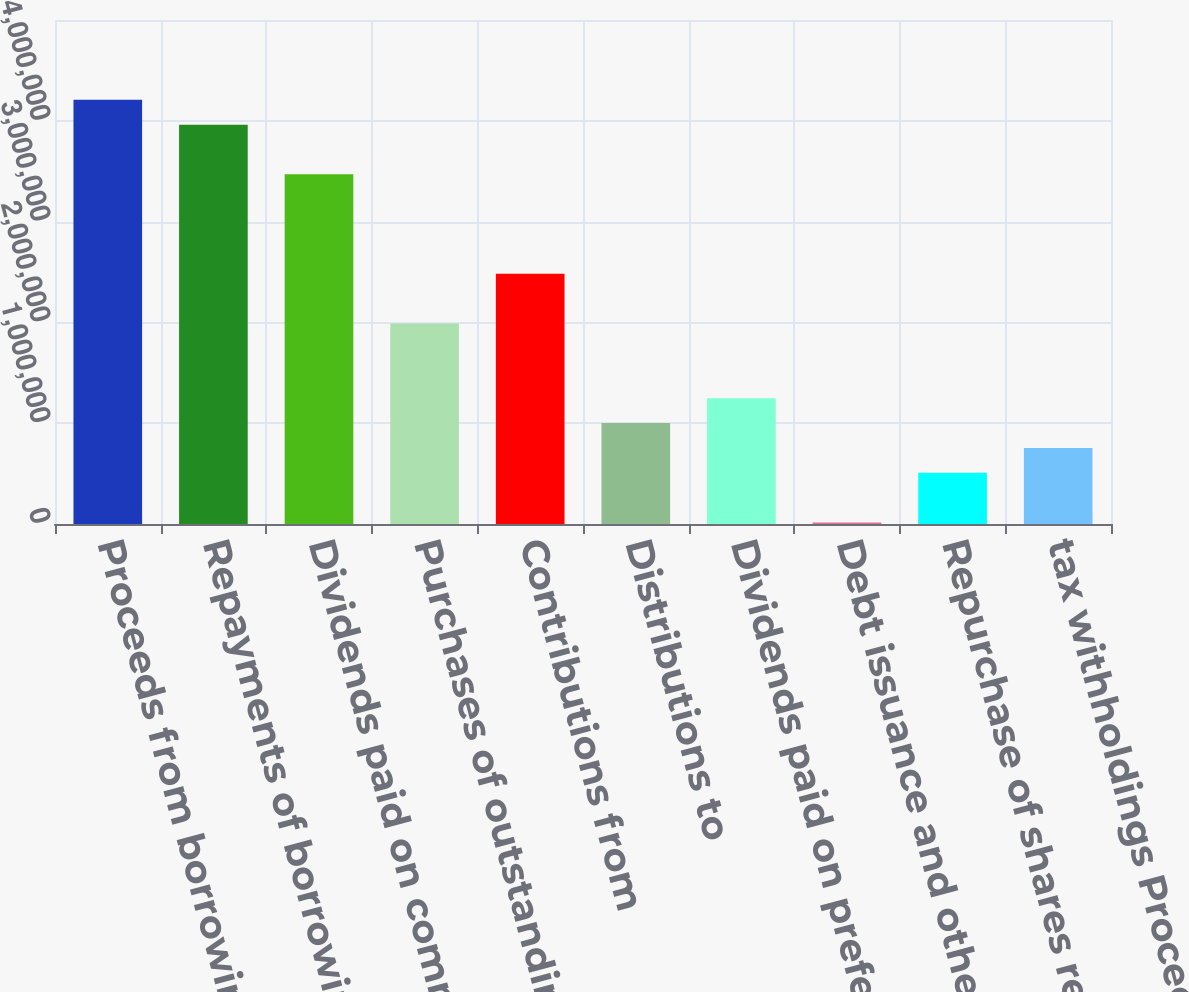Convert chart. <chart><loc_0><loc_0><loc_500><loc_500><bar_chart><fcel>Proceeds from borrowings<fcel>Repayments of borrowings<fcel>Dividends paid on common<fcel>Purchases of outstanding<fcel>Contributions from<fcel>Distributions to<fcel>Dividends paid on preferred<fcel>Debt issuance and other costs<fcel>Repurchase of shares related<fcel>tax withholdings Proceeds<nl><fcel>4.20872e+06<fcel>3.96202e+06<fcel>3.46864e+06<fcel>1.9885e+06<fcel>2.48188e+06<fcel>1.00174e+06<fcel>1.24843e+06<fcel>14980<fcel>508361<fcel>755051<nl></chart> 